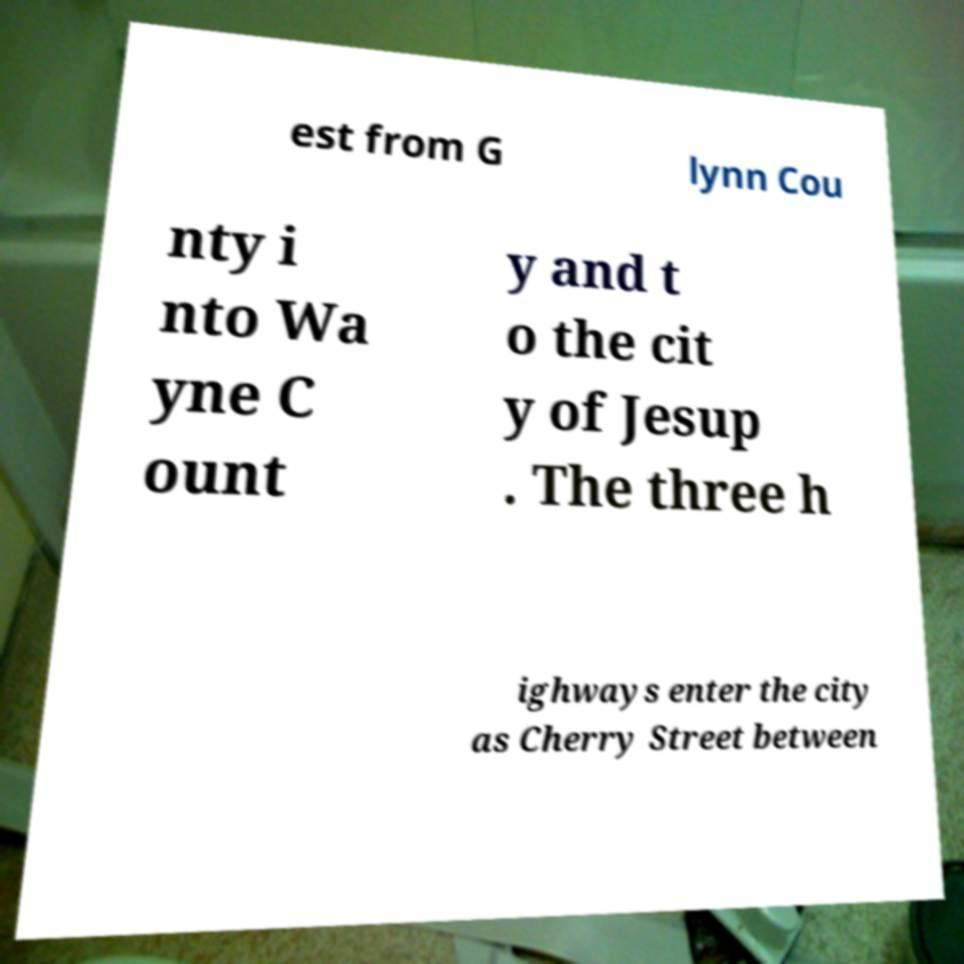For documentation purposes, I need the text within this image transcribed. Could you provide that? est from G lynn Cou nty i nto Wa yne C ount y and t o the cit y of Jesup . The three h ighways enter the city as Cherry Street between 